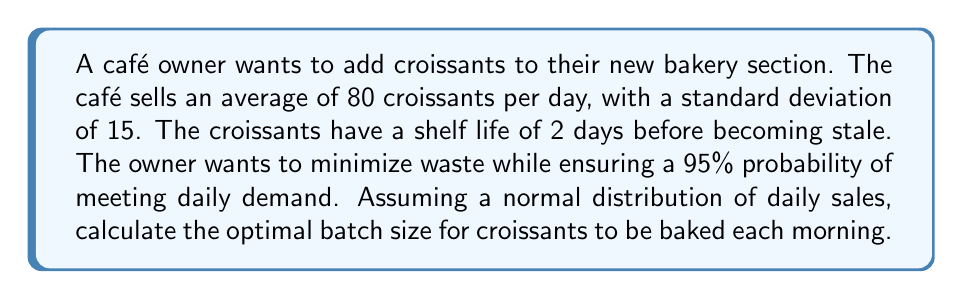Could you help me with this problem? To solve this problem, we'll follow these steps:

1) First, we need to determine the z-score for a 95% probability. From a standard normal distribution table, we find that this z-score is approximately 1.645.

2) The formula for calculating the optimal batch size (Q) is:

   $$Q = \mu + z\sigma$$

   Where:
   $\mu$ = mean daily demand
   $z$ = z-score for desired probability
   $\sigma$ = standard deviation of daily demand

3) We're given:
   $\mu = 80$
   $\sigma = 15$
   $z = 1.645$

4) Plugging these values into our formula:

   $$Q = 80 + (1.645 * 15)$$

5) Solving:
   $$Q = 80 + 24.675$$
   $$Q = 104.675$$

6) Since we can't bake a fractional croissant, we round up to the nearest whole number to ensure we meet the 95% probability threshold.

   $$Q = 105$$

Therefore, the optimal batch size is 105 croissants.
Answer: 105 croissants 